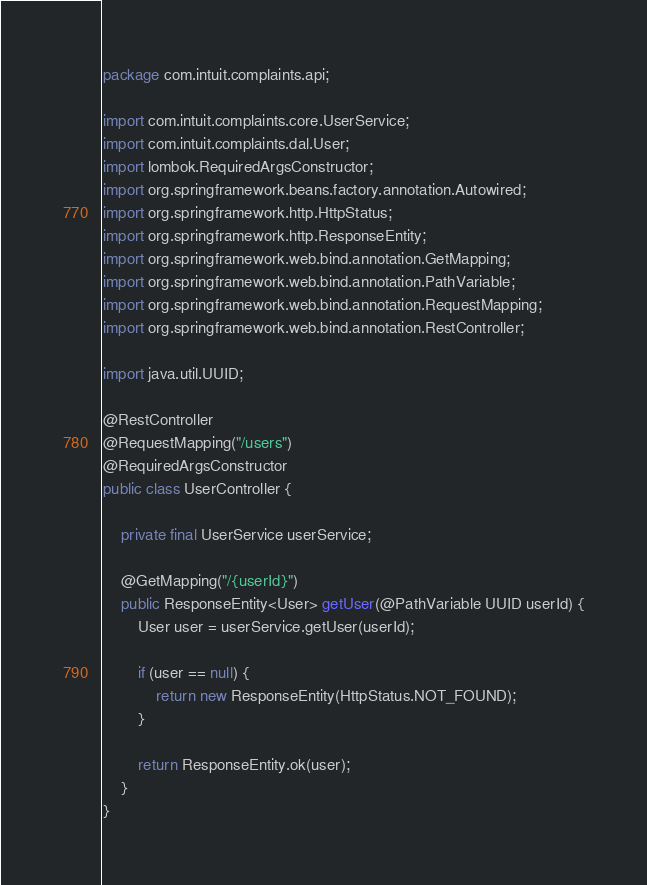<code> <loc_0><loc_0><loc_500><loc_500><_Java_>package com.intuit.complaints.api;

import com.intuit.complaints.core.UserService;
import com.intuit.complaints.dal.User;
import lombok.RequiredArgsConstructor;
import org.springframework.beans.factory.annotation.Autowired;
import org.springframework.http.HttpStatus;
import org.springframework.http.ResponseEntity;
import org.springframework.web.bind.annotation.GetMapping;
import org.springframework.web.bind.annotation.PathVariable;
import org.springframework.web.bind.annotation.RequestMapping;
import org.springframework.web.bind.annotation.RestController;

import java.util.UUID;

@RestController
@RequestMapping("/users")
@RequiredArgsConstructor
public class UserController {

    private final UserService userService;

    @GetMapping("/{userId}")
    public ResponseEntity<User> getUser(@PathVariable UUID userId) {
        User user = userService.getUser(userId);

        if (user == null) {
            return new ResponseEntity(HttpStatus.NOT_FOUND);
        }

        return ResponseEntity.ok(user);
    }
}
</code> 